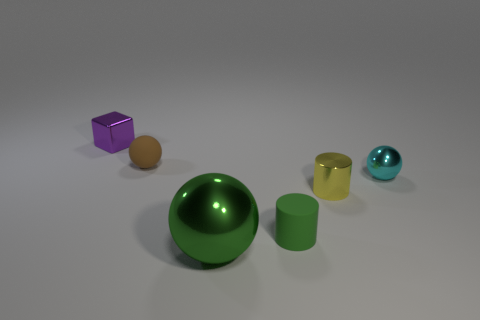Are there any other things that have the same size as the green metallic thing?
Keep it short and to the point. No. Does the purple object have the same material as the green cylinder?
Offer a very short reply. No. There is a object that is both right of the small purple shiny cube and left of the big green shiny object; what material is it?
Provide a succinct answer. Rubber. What number of other objects are the same material as the large green object?
Provide a succinct answer. 3. What number of small objects have the same color as the large object?
Your response must be concise. 1. How big is the green metallic ball in front of the metal sphere on the right side of the cylinder that is on the left side of the shiny cylinder?
Ensure brevity in your answer.  Large. How many rubber things are either large blue spheres or big green balls?
Offer a terse response. 0. Do the green matte thing and the tiny metal thing that is in front of the small cyan metal ball have the same shape?
Give a very brief answer. Yes. Are there more tiny purple objects that are behind the purple shiny object than brown things that are in front of the brown sphere?
Offer a very short reply. No. Is there anything else of the same color as the matte cylinder?
Offer a very short reply. Yes. 